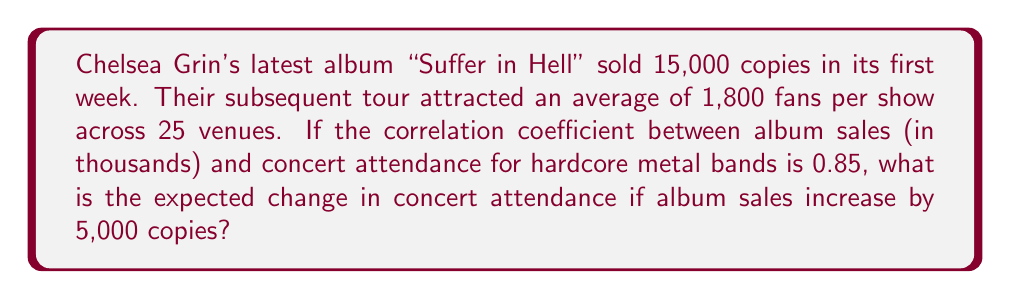Teach me how to tackle this problem. To solve this problem, we'll use the correlation coefficient formula and the concept of standard deviations. Let's break it down step-by-step:

1) The correlation coefficient (r) is given as 0.85.

2) The formula for the correlation coefficient is:
   $$r = \frac{\text{Cov}(X,Y)}{\sigma_X \sigma_Y}$$
   where Cov(X,Y) is the covariance, and $\sigma_X$ and $\sigma_Y$ are the standard deviations of X and Y respectively.

3) We can rearrange this to:
   $$\text{Cov}(X,Y) = r \sigma_X \sigma_Y$$

4) The change in Y (concert attendance) for a change in X (album sales) is given by:
   $$\frac{\Delta Y}{\Delta X} = \frac{\text{Cov}(X,Y)}{\sigma_X^2} = r \frac{\sigma_Y}{\sigma_X}$$

5) We don't have the standard deviations, but we can estimate them:
   For album sales: $\sigma_X \approx 15$ (assuming 15,000 is about one standard deviation)
   For concert attendance: $\sigma_Y \approx 1800$ (assuming the average is about one standard deviation)

6) Now we can calculate:
   $$\frac{\Delta Y}{\Delta X} = 0.85 \frac{1800}{15} = 102$$

7) This means for every 1,000 increase in album sales, we expect an increase of 102 in concert attendance.

8) For an increase of 5,000 album sales:
   $$5 * 102 = 510$$

Therefore, we expect an increase of 510 in concert attendance.
Answer: 510 attendees 